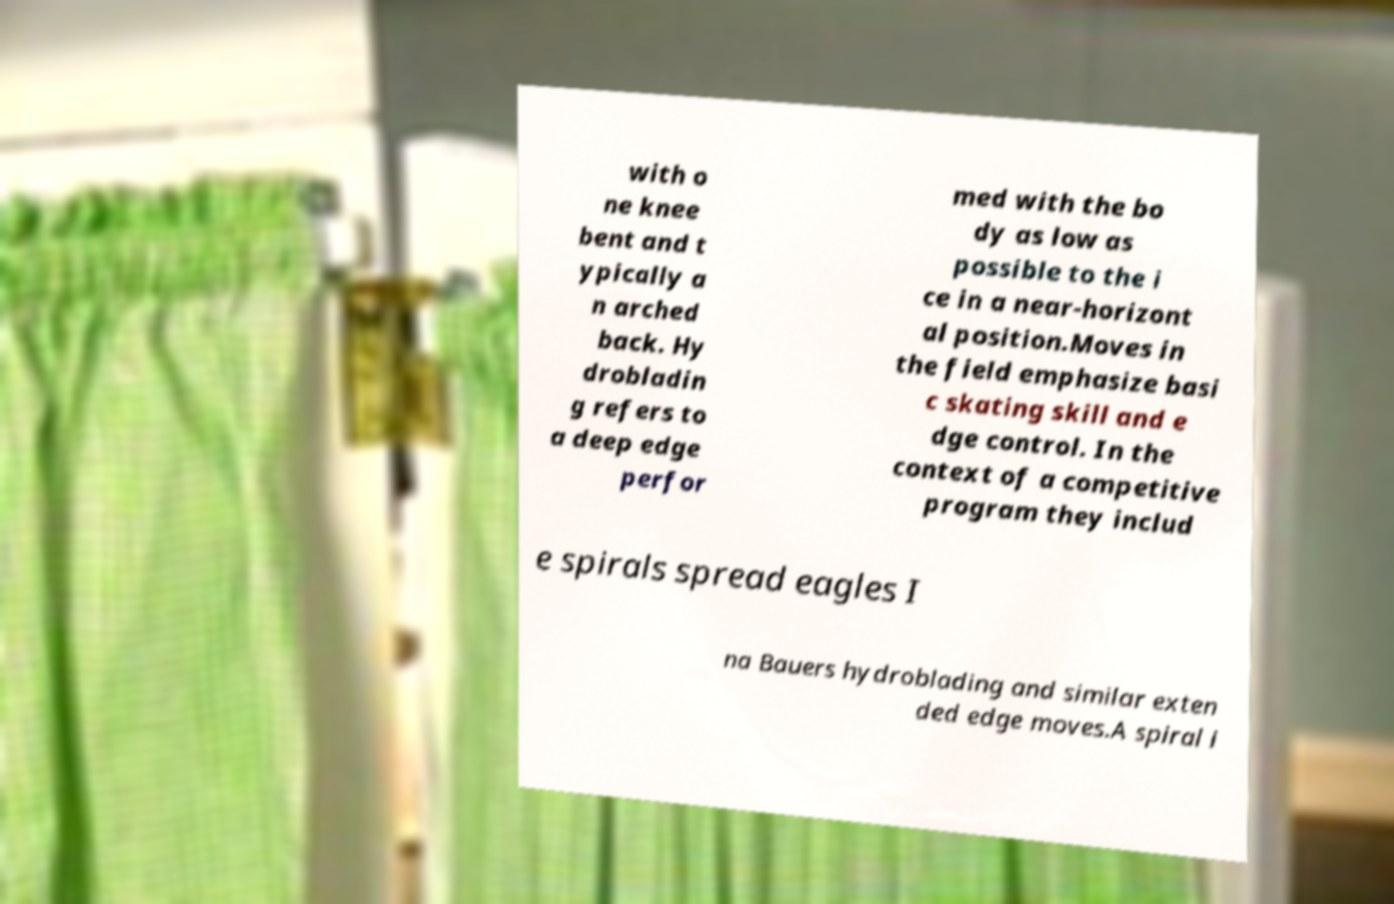Please identify and transcribe the text found in this image. with o ne knee bent and t ypically a n arched back. Hy drobladin g refers to a deep edge perfor med with the bo dy as low as possible to the i ce in a near-horizont al position.Moves in the field emphasize basi c skating skill and e dge control. In the context of a competitive program they includ e spirals spread eagles I na Bauers hydroblading and similar exten ded edge moves.A spiral i 